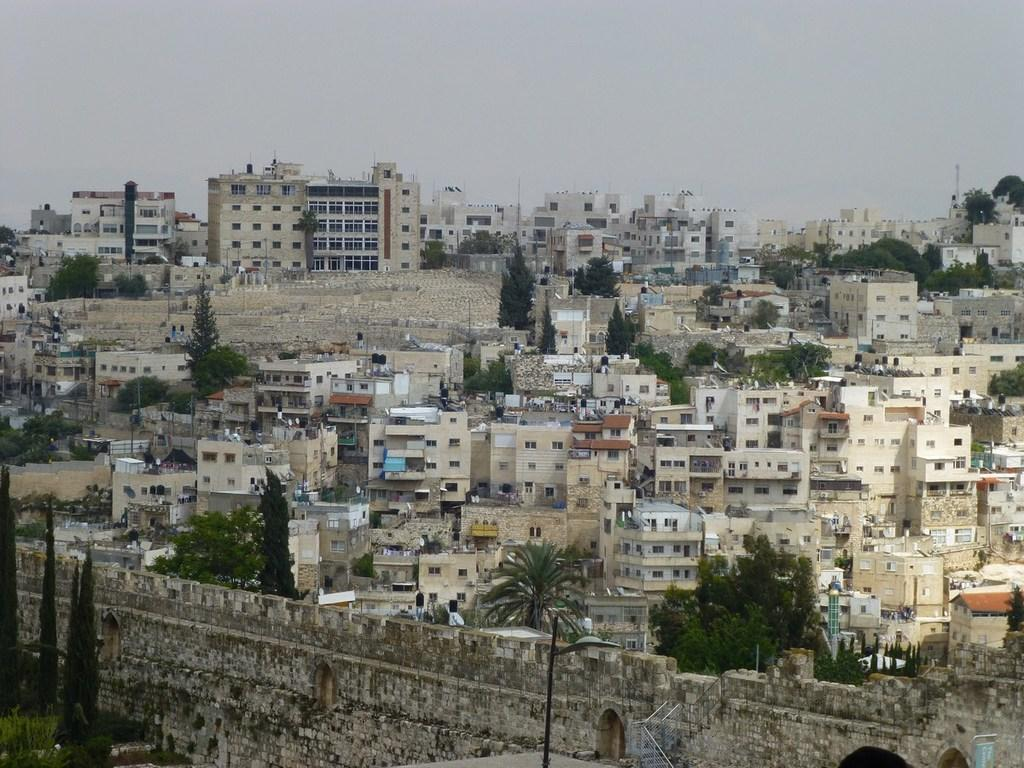What types of structures are visible in the image? There are multiple buildings in the image. What other natural elements can be seen in the image? There are trees in the image. What objects are present on the left side of the image? There are poles on the left side of the image. What is visible in the background of the image? The sky is visible in the background of the image. How many amusement rides can be seen in the image? There are no amusement rides present in the image. What type of clock is visible on the buildings in the image? There are no clocks visible on the buildings in the image. 